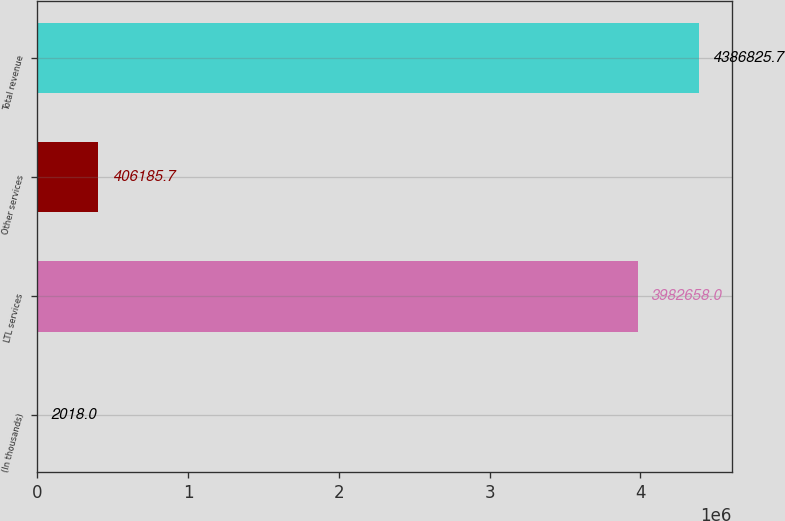<chart> <loc_0><loc_0><loc_500><loc_500><bar_chart><fcel>(In thousands)<fcel>LTL services<fcel>Other services<fcel>Total revenue<nl><fcel>2018<fcel>3.98266e+06<fcel>406186<fcel>4.38683e+06<nl></chart> 